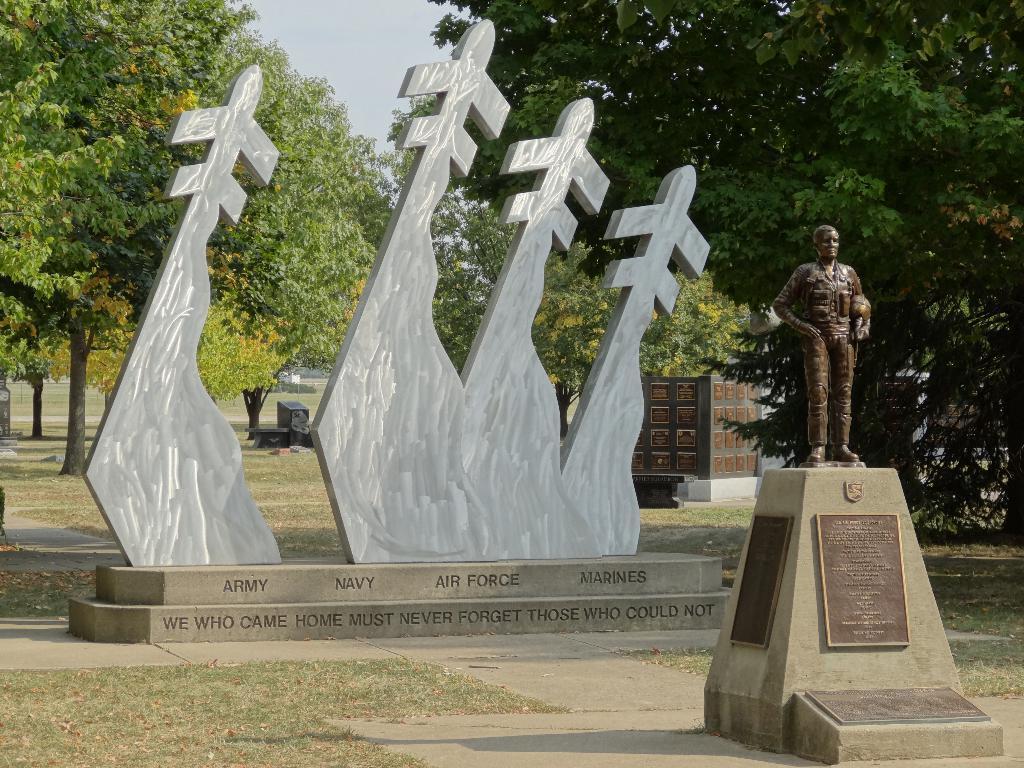Please provide a concise description of this image. In this picture we can see a statue on the right side, there is a monument in the middle, in the background there are some trees and grass, we can see the sky at the top of the picture. 